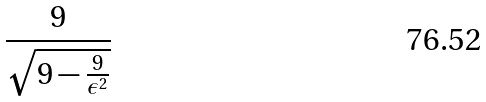Convert formula to latex. <formula><loc_0><loc_0><loc_500><loc_500>\frac { 9 } { \sqrt { 9 - \frac { 9 } { \epsilon ^ { 2 } } } }</formula> 